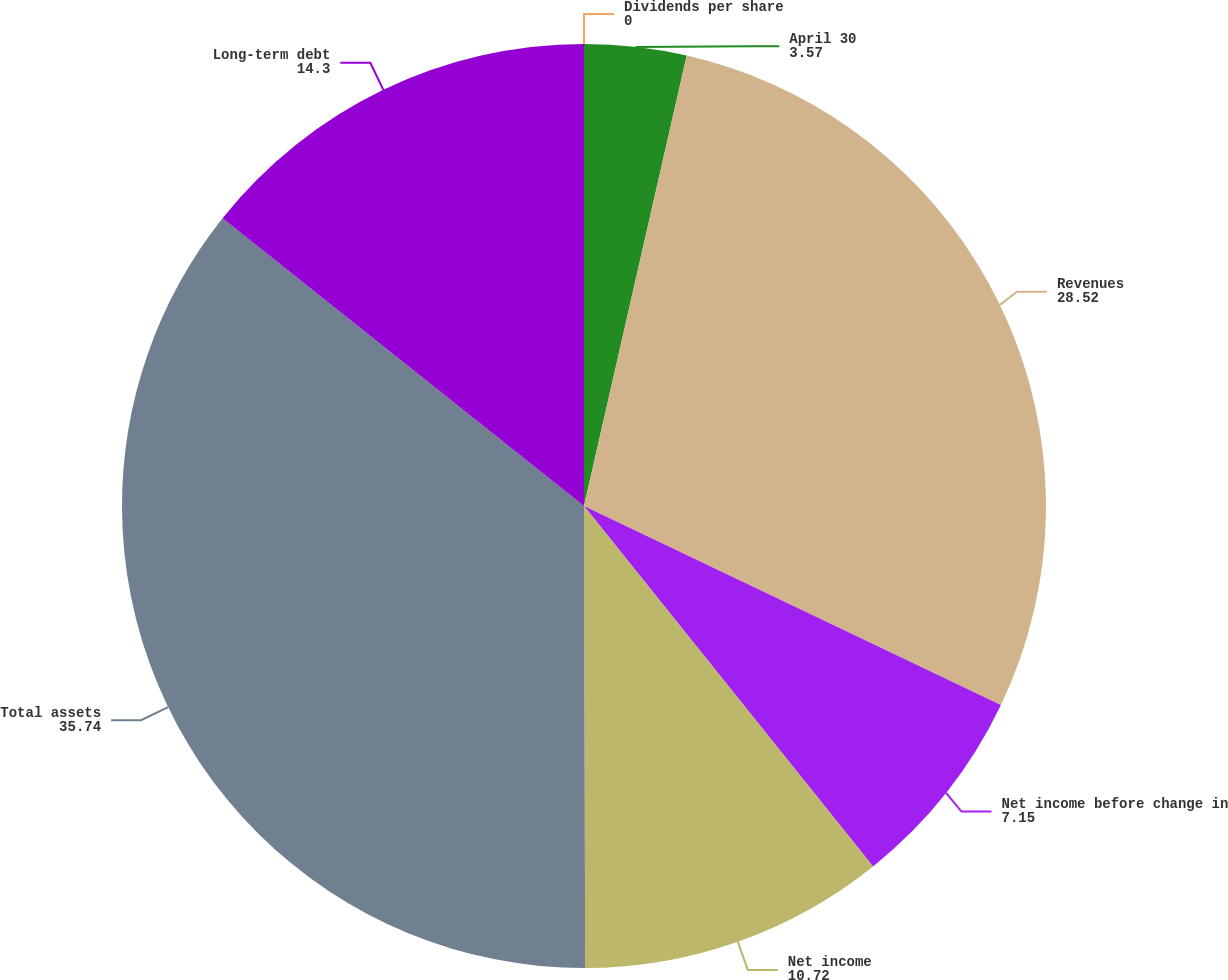Convert chart. <chart><loc_0><loc_0><loc_500><loc_500><pie_chart><fcel>April 30<fcel>Revenues<fcel>Net income before change in<fcel>Net income<fcel>Total assets<fcel>Long-term debt<fcel>Dividends per share<nl><fcel>3.57%<fcel>28.52%<fcel>7.15%<fcel>10.72%<fcel>35.74%<fcel>14.3%<fcel>0.0%<nl></chart> 